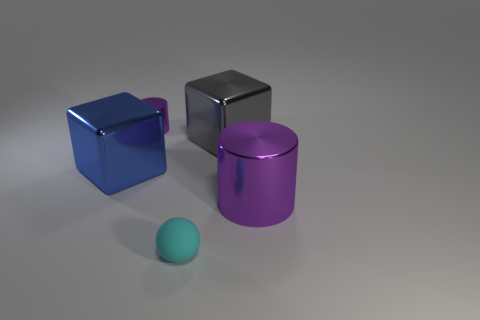Is the large cylinder the same color as the matte thing?
Provide a succinct answer. No. How many red objects have the same size as the rubber ball?
Provide a short and direct response. 0. Are there more small cylinders that are in front of the large gray shiny block than metallic things that are in front of the small shiny thing?
Offer a terse response. No. There is a cylinder that is to the left of the metallic cylinder in front of the blue object; what is its color?
Provide a succinct answer. Purple. Is the blue thing made of the same material as the big cylinder?
Your response must be concise. Yes. Is there a large gray object that has the same shape as the cyan rubber object?
Your response must be concise. No. Do the metallic block left of the cyan sphere and the ball have the same color?
Offer a very short reply. No. There is a shiny cylinder on the right side of the sphere; is it the same size as the metallic block that is right of the blue thing?
Give a very brief answer. Yes. There is a cube that is made of the same material as the blue thing; what is its size?
Give a very brief answer. Large. What number of purple cylinders are both right of the cyan rubber ball and left of the big purple metallic object?
Keep it short and to the point. 0. 